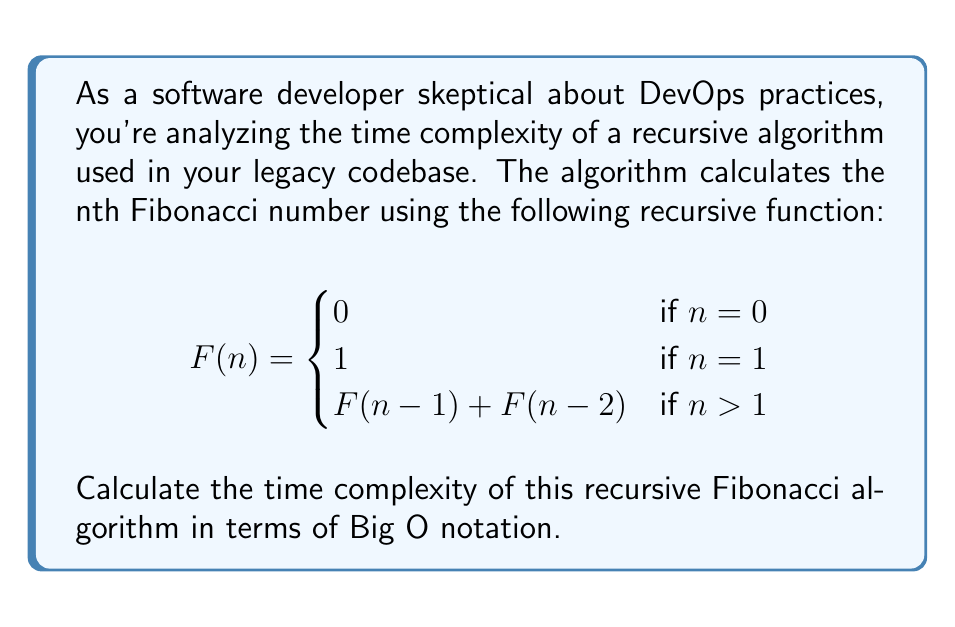Could you help me with this problem? To analyze the time complexity of this recursive Fibonacci algorithm, we'll follow these steps:

1) First, observe that for each call to F(n) where n > 1, the function makes two recursive calls: F(n-1) and F(n-2).

2) This creates a binary tree of recursive calls, where each node represents a function call.

3) The depth of this tree is n, as we reduce n by 1 or 2 in each recursive call until we reach the base cases (n = 0 or n = 1).

4) At each level of the tree, the number of nodes (function calls) approximately doubles.

5) The total number of nodes in the tree can be estimated as:

   $$1 + 2 + 2^2 + 2^3 + ... + 2^{n-1} = 2^n - 1$$

6) This sum is a geometric series with n terms, which simplifies to $2^n - 1$.

7) In Big O notation, we ignore constant factors and lower-order terms. Therefore, the time complexity is O($2^n$).

This exponential time complexity explains why the recursive Fibonacci algorithm becomes extremely slow for larger values of n, which might reinforce your skepticism about changing well-established code for the sake of DevOps practices.
Answer: O($2^n$) 